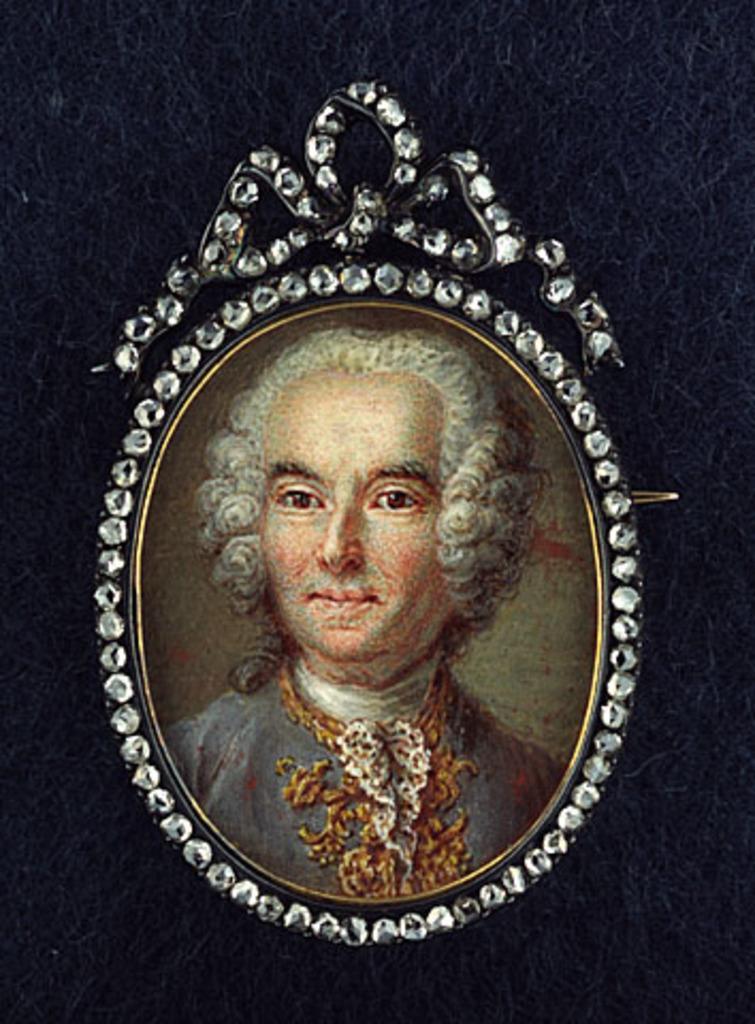In one or two sentences, can you explain what this image depicts? In this image there is a photo frame of a person which was attached to the wall. 